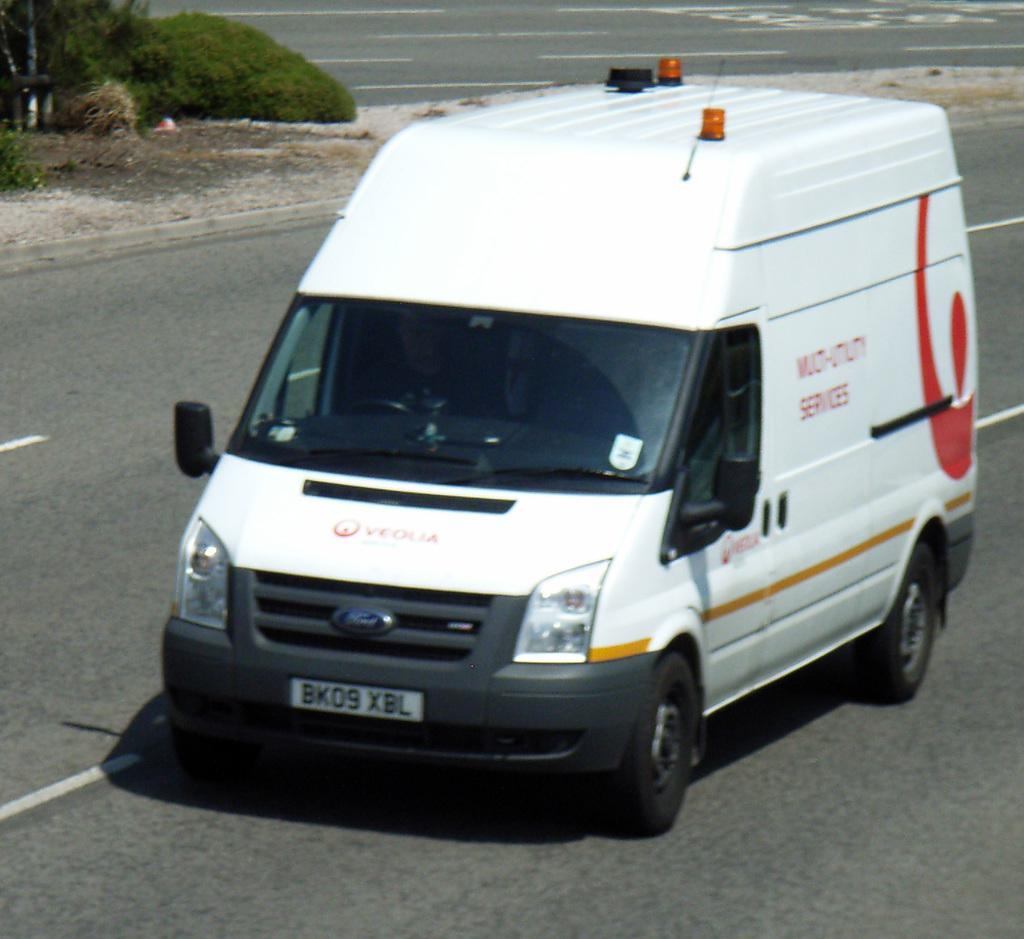<image>
Provide a brief description of the given image. a van that has the word services on it 